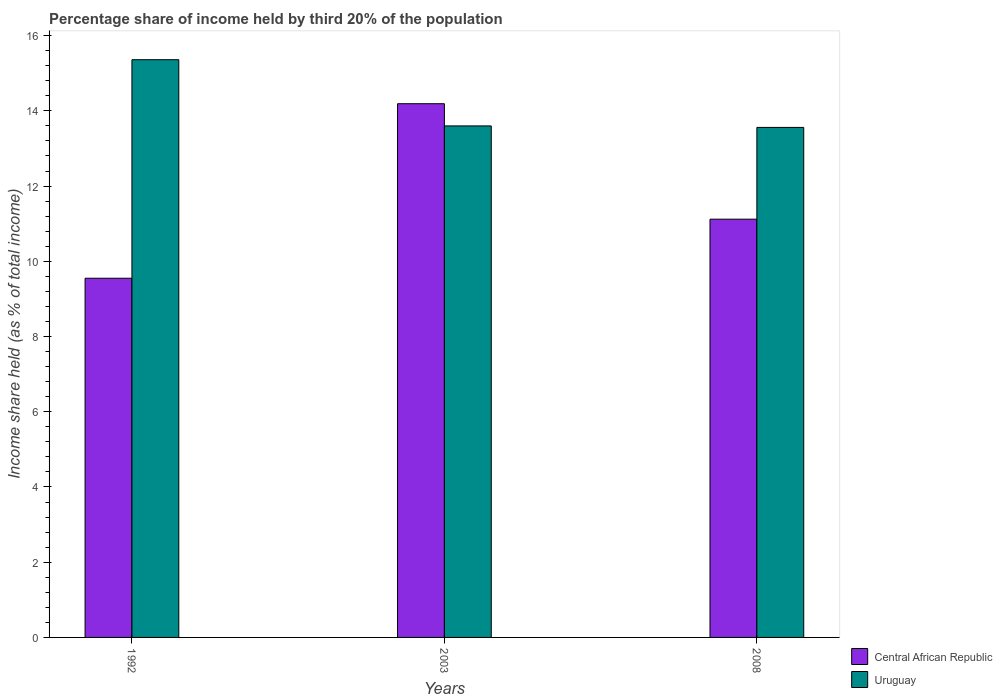How many groups of bars are there?
Make the answer very short. 3. Are the number of bars per tick equal to the number of legend labels?
Your answer should be very brief. Yes. What is the label of the 2nd group of bars from the left?
Give a very brief answer. 2003. What is the share of income held by third 20% of the population in Central African Republic in 1992?
Provide a succinct answer. 9.55. Across all years, what is the maximum share of income held by third 20% of the population in Central African Republic?
Ensure brevity in your answer.  14.19. Across all years, what is the minimum share of income held by third 20% of the population in Uruguay?
Give a very brief answer. 13.56. In which year was the share of income held by third 20% of the population in Central African Republic maximum?
Ensure brevity in your answer.  2003. In which year was the share of income held by third 20% of the population in Central African Republic minimum?
Provide a short and direct response. 1992. What is the total share of income held by third 20% of the population in Central African Republic in the graph?
Make the answer very short. 34.86. What is the difference between the share of income held by third 20% of the population in Uruguay in 1992 and that in 2008?
Offer a terse response. 1.8. What is the difference between the share of income held by third 20% of the population in Uruguay in 1992 and the share of income held by third 20% of the population in Central African Republic in 2003?
Give a very brief answer. 1.17. What is the average share of income held by third 20% of the population in Central African Republic per year?
Keep it short and to the point. 11.62. In the year 2003, what is the difference between the share of income held by third 20% of the population in Central African Republic and share of income held by third 20% of the population in Uruguay?
Make the answer very short. 0.59. What is the ratio of the share of income held by third 20% of the population in Central African Republic in 1992 to that in 2003?
Give a very brief answer. 0.67. Is the difference between the share of income held by third 20% of the population in Central African Republic in 2003 and 2008 greater than the difference between the share of income held by third 20% of the population in Uruguay in 2003 and 2008?
Give a very brief answer. Yes. What is the difference between the highest and the second highest share of income held by third 20% of the population in Uruguay?
Your response must be concise. 1.76. What is the difference between the highest and the lowest share of income held by third 20% of the population in Central African Republic?
Your answer should be compact. 4.64. In how many years, is the share of income held by third 20% of the population in Uruguay greater than the average share of income held by third 20% of the population in Uruguay taken over all years?
Keep it short and to the point. 1. What does the 2nd bar from the left in 1992 represents?
Offer a very short reply. Uruguay. What does the 2nd bar from the right in 1992 represents?
Provide a short and direct response. Central African Republic. How many bars are there?
Provide a succinct answer. 6. What is the difference between two consecutive major ticks on the Y-axis?
Ensure brevity in your answer.  2. Are the values on the major ticks of Y-axis written in scientific E-notation?
Offer a terse response. No. Does the graph contain any zero values?
Your answer should be very brief. No. How many legend labels are there?
Give a very brief answer. 2. How are the legend labels stacked?
Offer a terse response. Vertical. What is the title of the graph?
Your answer should be very brief. Percentage share of income held by third 20% of the population. What is the label or title of the Y-axis?
Provide a short and direct response. Income share held (as % of total income). What is the Income share held (as % of total income) of Central African Republic in 1992?
Provide a succinct answer. 9.55. What is the Income share held (as % of total income) in Uruguay in 1992?
Offer a very short reply. 15.36. What is the Income share held (as % of total income) in Central African Republic in 2003?
Offer a terse response. 14.19. What is the Income share held (as % of total income) in Central African Republic in 2008?
Your response must be concise. 11.12. What is the Income share held (as % of total income) in Uruguay in 2008?
Your answer should be very brief. 13.56. Across all years, what is the maximum Income share held (as % of total income) in Central African Republic?
Offer a very short reply. 14.19. Across all years, what is the maximum Income share held (as % of total income) in Uruguay?
Give a very brief answer. 15.36. Across all years, what is the minimum Income share held (as % of total income) of Central African Republic?
Offer a very short reply. 9.55. Across all years, what is the minimum Income share held (as % of total income) of Uruguay?
Provide a short and direct response. 13.56. What is the total Income share held (as % of total income) of Central African Republic in the graph?
Your answer should be compact. 34.86. What is the total Income share held (as % of total income) of Uruguay in the graph?
Ensure brevity in your answer.  42.52. What is the difference between the Income share held (as % of total income) in Central African Republic in 1992 and that in 2003?
Ensure brevity in your answer.  -4.64. What is the difference between the Income share held (as % of total income) of Uruguay in 1992 and that in 2003?
Make the answer very short. 1.76. What is the difference between the Income share held (as % of total income) in Central African Republic in 1992 and that in 2008?
Your answer should be very brief. -1.57. What is the difference between the Income share held (as % of total income) in Central African Republic in 2003 and that in 2008?
Keep it short and to the point. 3.07. What is the difference between the Income share held (as % of total income) in Uruguay in 2003 and that in 2008?
Provide a short and direct response. 0.04. What is the difference between the Income share held (as % of total income) in Central African Republic in 1992 and the Income share held (as % of total income) in Uruguay in 2003?
Offer a very short reply. -4.05. What is the difference between the Income share held (as % of total income) in Central African Republic in 1992 and the Income share held (as % of total income) in Uruguay in 2008?
Provide a short and direct response. -4.01. What is the difference between the Income share held (as % of total income) of Central African Republic in 2003 and the Income share held (as % of total income) of Uruguay in 2008?
Give a very brief answer. 0.63. What is the average Income share held (as % of total income) of Central African Republic per year?
Provide a succinct answer. 11.62. What is the average Income share held (as % of total income) in Uruguay per year?
Give a very brief answer. 14.17. In the year 1992, what is the difference between the Income share held (as % of total income) in Central African Republic and Income share held (as % of total income) in Uruguay?
Provide a short and direct response. -5.81. In the year 2003, what is the difference between the Income share held (as % of total income) in Central African Republic and Income share held (as % of total income) in Uruguay?
Provide a succinct answer. 0.59. In the year 2008, what is the difference between the Income share held (as % of total income) in Central African Republic and Income share held (as % of total income) in Uruguay?
Keep it short and to the point. -2.44. What is the ratio of the Income share held (as % of total income) of Central African Republic in 1992 to that in 2003?
Your response must be concise. 0.67. What is the ratio of the Income share held (as % of total income) of Uruguay in 1992 to that in 2003?
Offer a very short reply. 1.13. What is the ratio of the Income share held (as % of total income) of Central African Republic in 1992 to that in 2008?
Your response must be concise. 0.86. What is the ratio of the Income share held (as % of total income) of Uruguay in 1992 to that in 2008?
Offer a very short reply. 1.13. What is the ratio of the Income share held (as % of total income) in Central African Republic in 2003 to that in 2008?
Make the answer very short. 1.28. What is the ratio of the Income share held (as % of total income) of Uruguay in 2003 to that in 2008?
Give a very brief answer. 1. What is the difference between the highest and the second highest Income share held (as % of total income) in Central African Republic?
Your answer should be compact. 3.07. What is the difference between the highest and the second highest Income share held (as % of total income) in Uruguay?
Offer a very short reply. 1.76. What is the difference between the highest and the lowest Income share held (as % of total income) in Central African Republic?
Your answer should be very brief. 4.64. What is the difference between the highest and the lowest Income share held (as % of total income) of Uruguay?
Keep it short and to the point. 1.8. 